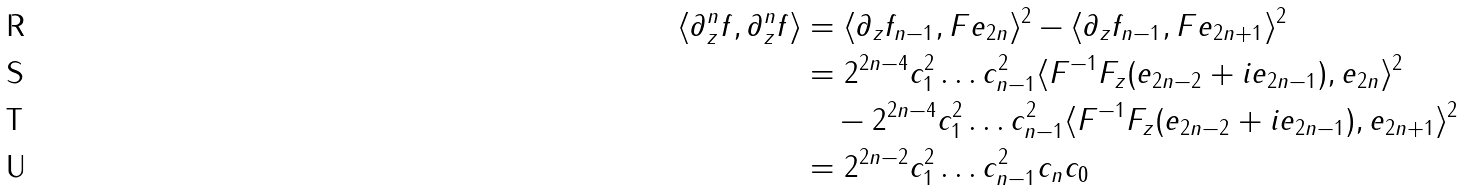Convert formula to latex. <formula><loc_0><loc_0><loc_500><loc_500>\langle \partial _ { z } ^ { n } f , \partial _ { z } ^ { n } f \rangle & = \langle \partial _ { z } f _ { n - 1 } , F e _ { 2 n } \rangle ^ { 2 } - \langle \partial _ { z } f _ { n - 1 } , F e _ { 2 n + 1 } \rangle ^ { 2 } \\ & = 2 ^ { 2 n - 4 } c _ { 1 } ^ { 2 } \dots c _ { n - 1 } ^ { 2 } \langle F ^ { - 1 } F _ { z } ( e _ { 2 n - 2 } + i e _ { 2 n - 1 } ) , e _ { 2 n } \rangle ^ { 2 } \\ & \quad - 2 ^ { 2 n - 4 } c _ { 1 } ^ { 2 } \dots c _ { n - 1 } ^ { 2 } \langle F ^ { - 1 } F _ { z } ( e _ { 2 n - 2 } + i e _ { 2 n - 1 } ) , e _ { 2 n + 1 } \rangle ^ { 2 } \\ & = 2 ^ { 2 n - 2 } c _ { 1 } ^ { 2 } \dots c _ { n - 1 } ^ { 2 } c _ { n } c _ { 0 }</formula> 